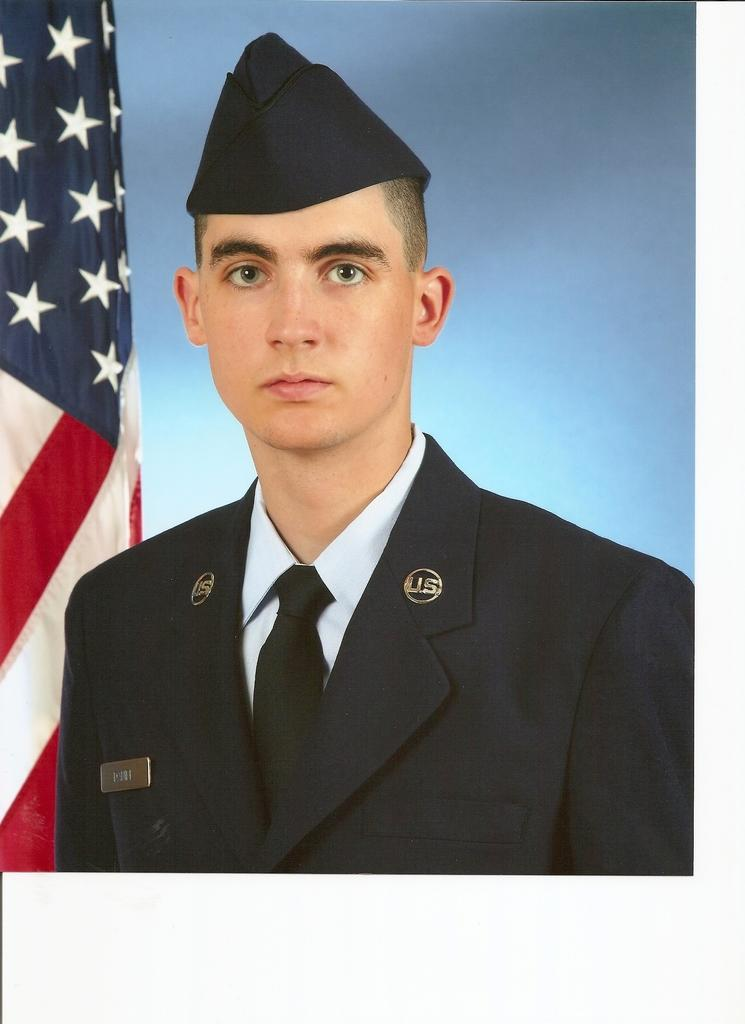Who is present in the image? There is a person in the image. What is the person wearing? The person is wearing a black suit and a cap. What can be seen in the background of the image? There is a flag in the background of the image. What type of pie is the person holding in the image? There is no pie present in the image; the person is wearing a black suit and a cap, and there is a flag in the background. 